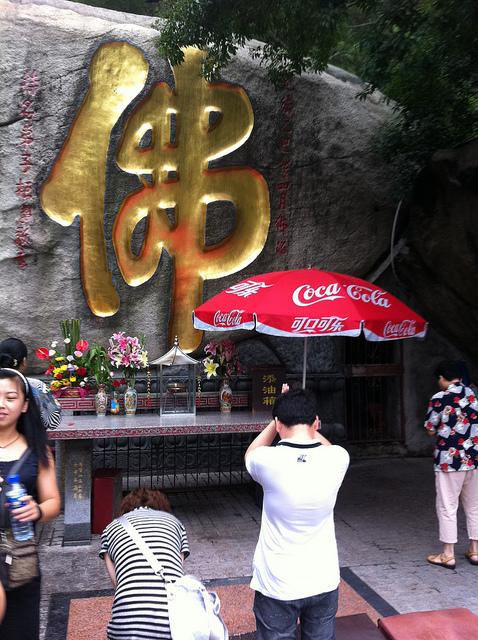What Pantone is Coca Cola red? Please explain your reasoning. pms484. According to google the pantone color for coke is pms-484. 